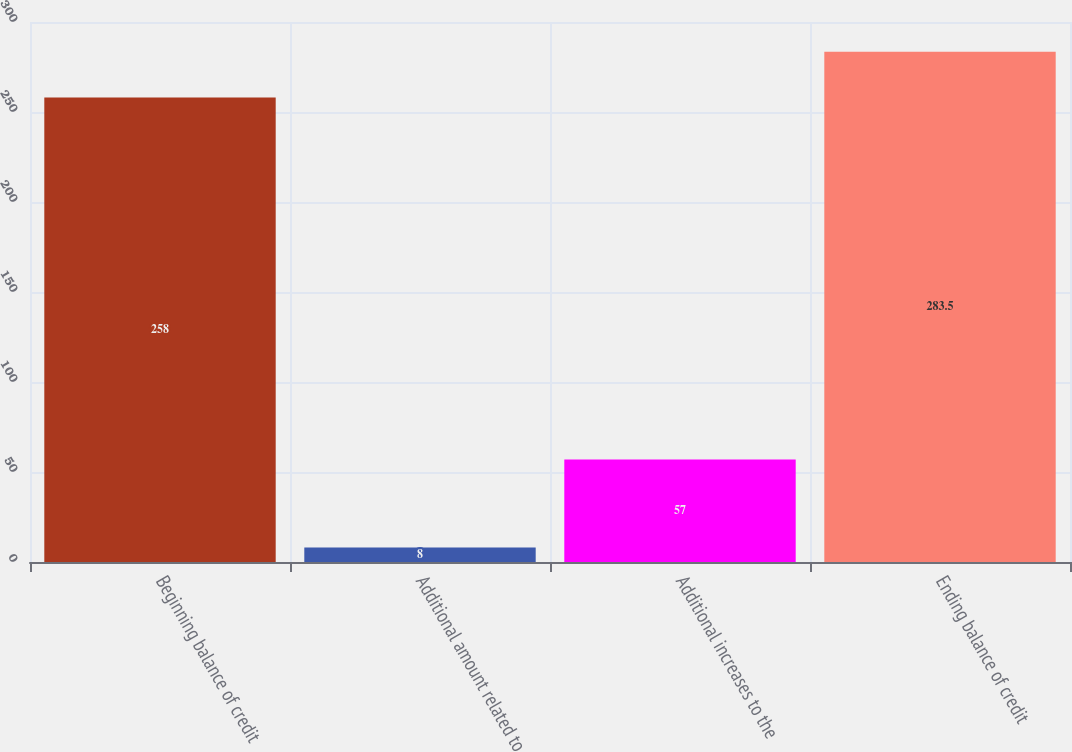Convert chart to OTSL. <chart><loc_0><loc_0><loc_500><loc_500><bar_chart><fcel>Beginning balance of credit<fcel>Additional amount related to<fcel>Additional increases to the<fcel>Ending balance of credit<nl><fcel>258<fcel>8<fcel>57<fcel>283.5<nl></chart> 